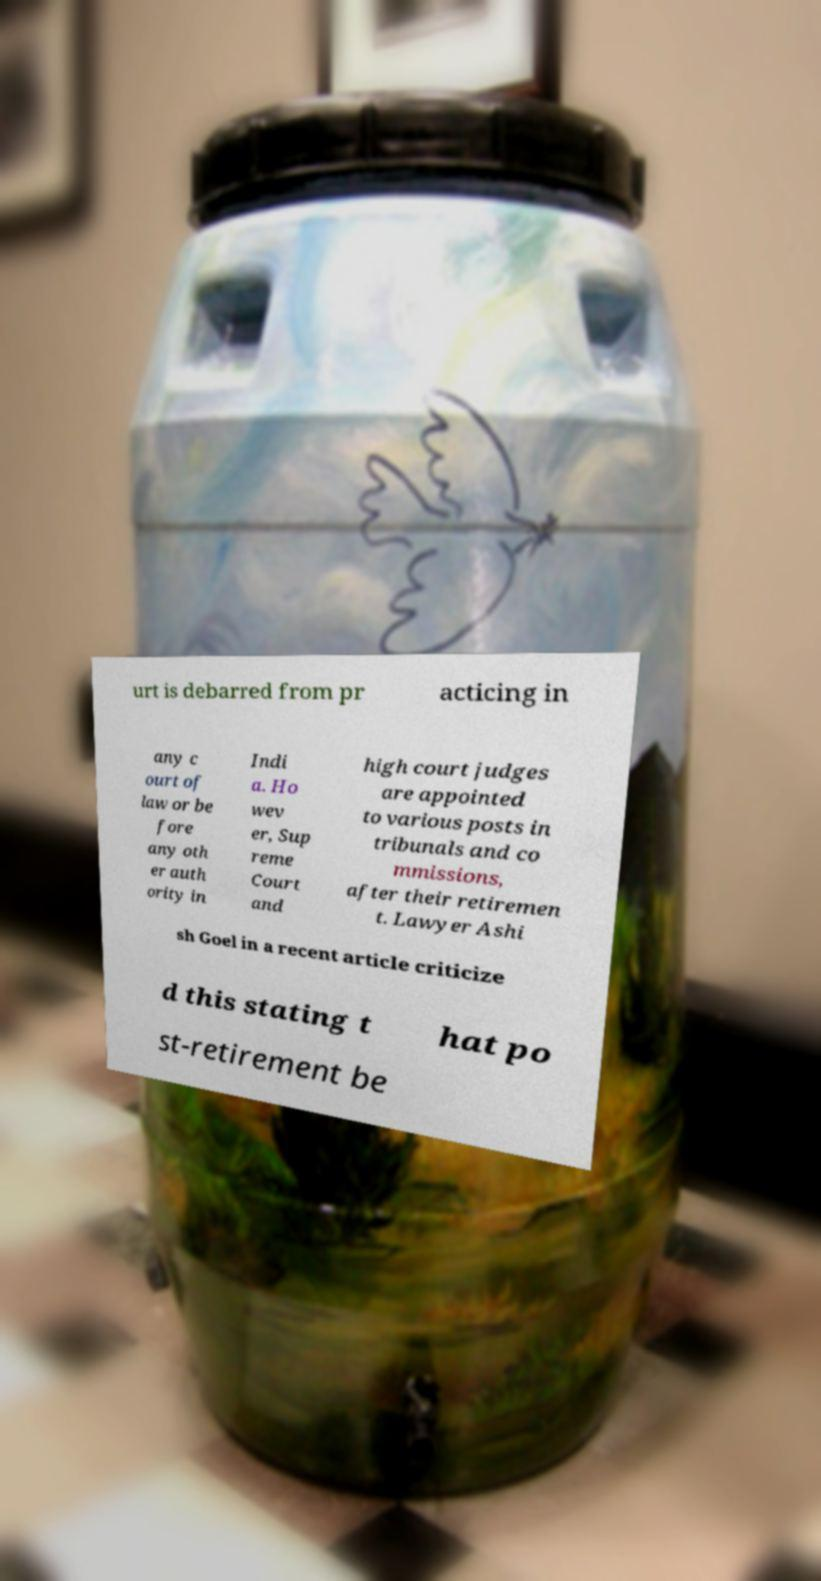Please read and relay the text visible in this image. What does it say? urt is debarred from pr acticing in any c ourt of law or be fore any oth er auth ority in Indi a. Ho wev er, Sup reme Court and high court judges are appointed to various posts in tribunals and co mmissions, after their retiremen t. Lawyer Ashi sh Goel in a recent article criticize d this stating t hat po st-retirement be 